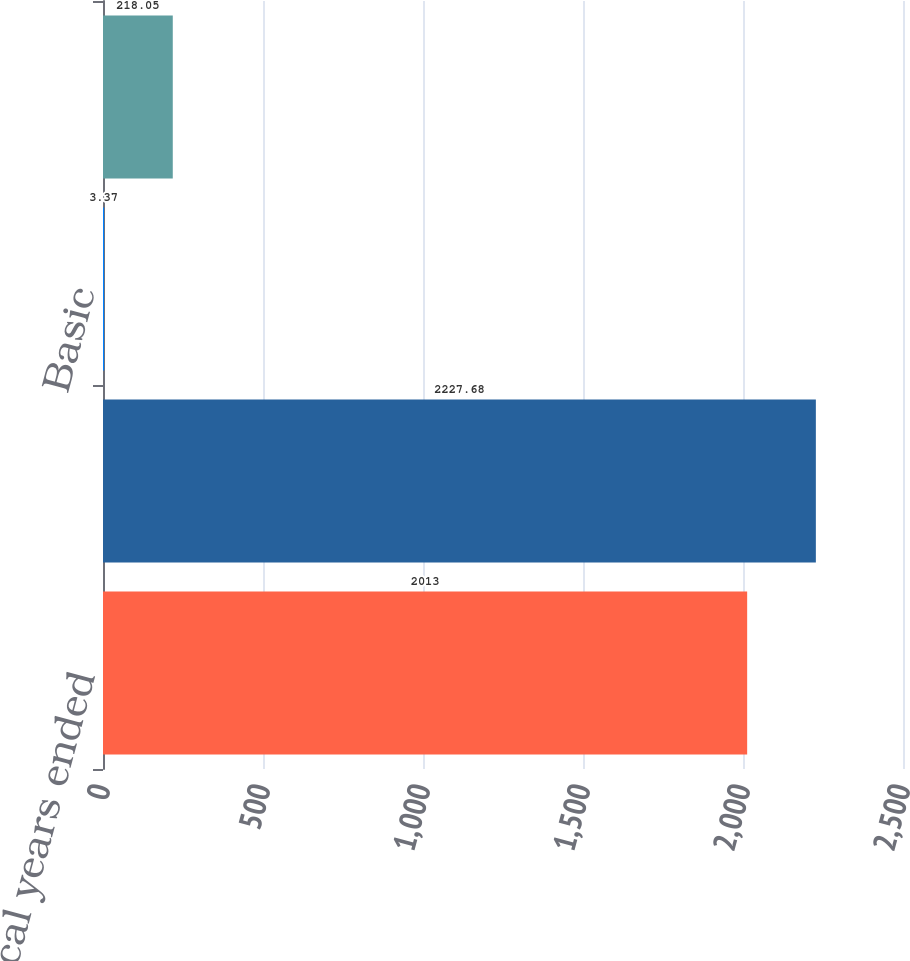<chart> <loc_0><loc_0><loc_500><loc_500><bar_chart><fcel>for the fiscal years ended<fcel>Net Income Attributable to<fcel>Basic<fcel>Diluted<nl><fcel>2013<fcel>2227.68<fcel>3.37<fcel>218.05<nl></chart> 